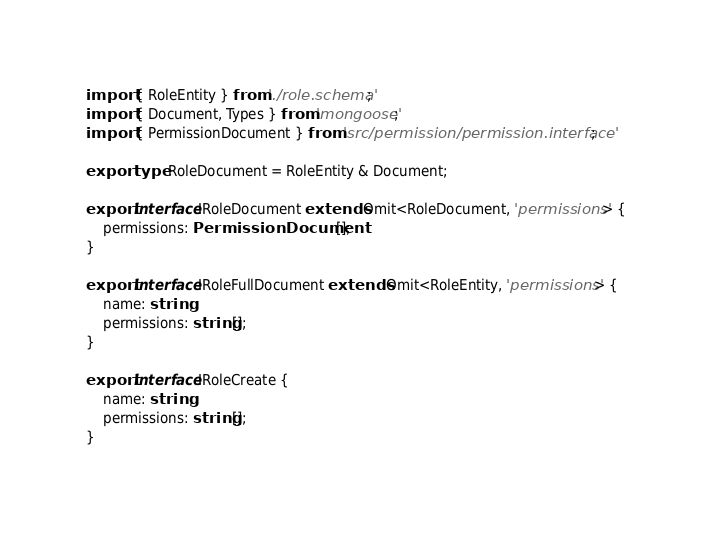Convert code to text. <code><loc_0><loc_0><loc_500><loc_500><_TypeScript_>import { RoleEntity } from './role.schema';
import { Document, Types } from 'mongoose';
import { PermissionDocument } from 'src/permission/permission.interface';

export type RoleDocument = RoleEntity & Document;

export interface IRoleDocument extends Omit<RoleDocument, 'permissions'> {
    permissions: PermissionDocument[];
}

export interface IRoleFullDocument extends Omit<RoleEntity, 'permissions'> {
    name: string;
    permissions: string[];
}

export interface IRoleCreate {
    name: string;
    permissions: string[];
}
</code> 